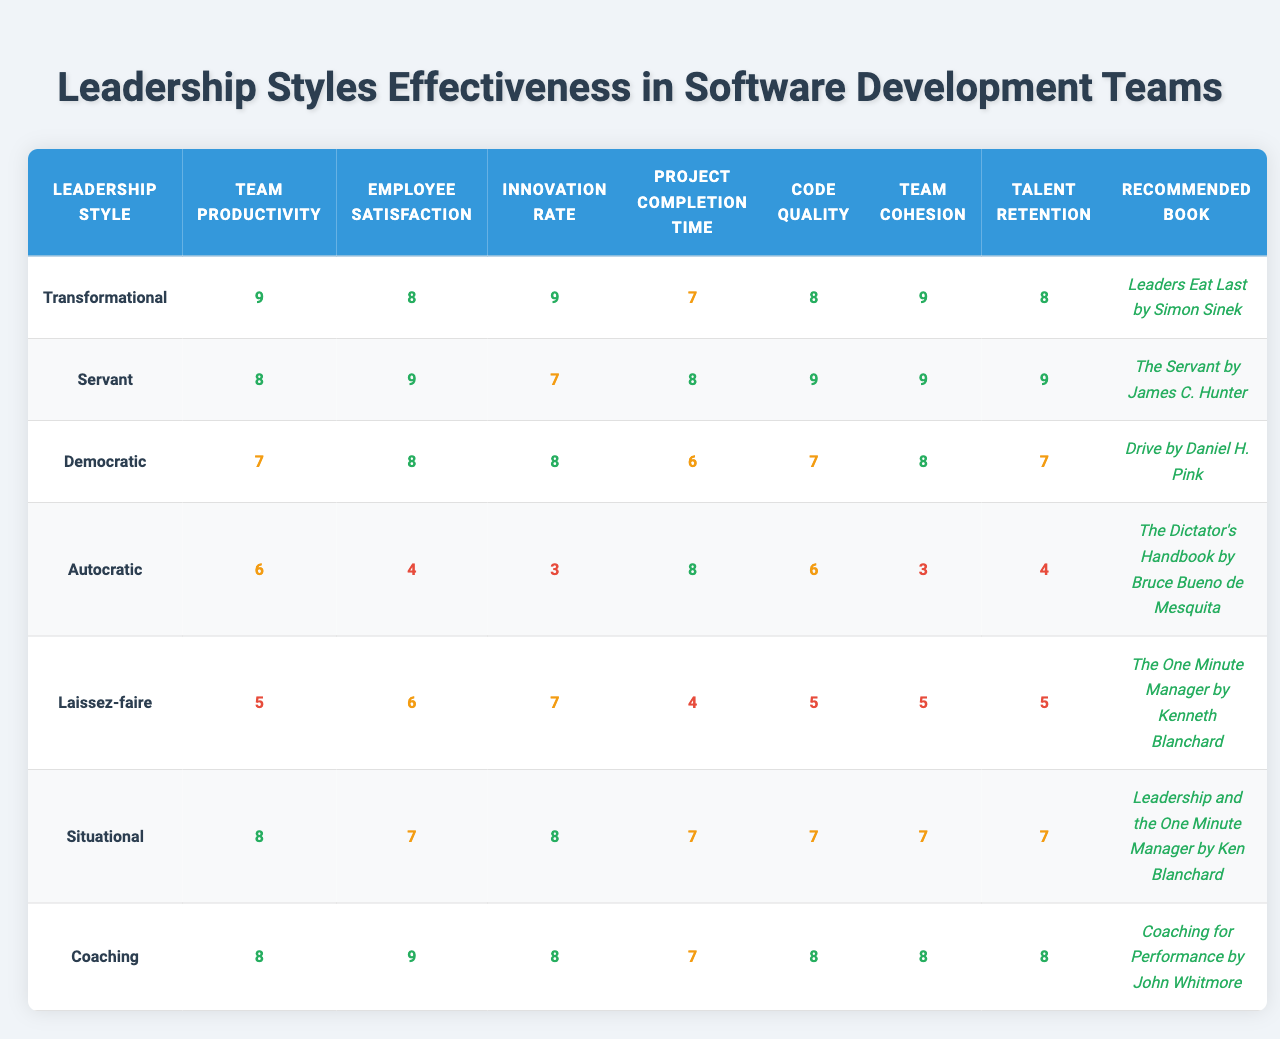What is the recommended book for the Transformational leadership style? According to the table, the recommended book for the Transformational leadership style is "Leaders Eat Last by Simon Sinek."
Answer: Leaders Eat Last by Simon Sinek Which leadership style has the highest score in Employee Satisfaction? The Employee Satisfaction scores for all styles are compared. The Servant leadership style has the highest score of 9.
Answer: Servant What is the average score for Team Cohesion across all leadership styles? The Team Cohesion scores are 9, 9, 8, 3, 5, 7, and 8. Adding these gives 49, and dividing by 7 (the number of styles) gives an average of 7.
Answer: 7 Does the Autocratic leadership style have a higher Innovation Rate than the Democratic style? The Innovation Rate for Autocratic is 3, while for Democratic it is 8. Since 3 is less than 8, the statement is false.
Answer: No What is the difference in Team Productivity between the Transformational and Laissez-faire leadership styles? Team Productivity for Transformational is 9 and for Laissez-faire is 5. The difference is 9 - 5 = 4.
Answer: 4 Which leadership style is associated with the lowest Code Quality score? The Code Quality scores are compared, and Autocratic has the lowest score of 6, making it the answer.
Answer: Autocratic If we consider the Talent Retention scores, which leadership style stands out as having a consistent high score? The scores for Talent Retention are 8, 9, 7, 4, 5, 7, and 8. The Servant style has the highest & consistent score of 9, indicating strong retention.
Answer: Servant What is the highest Project Completion Time score among all leadership styles? The Project Completion Time scores are 7, 8, 6, 8, 4, 7, and 7. The highest score is 8 from both Servant and Autocratic styles.
Answer: 8 Which leadership style has the lowest Team Cohesion score? Looking at the Team Cohesion scores, Autocratic has the lowest score of 3 when compared to others.
Answer: Autocratic Is there a leadership style that scores above 8 in both Team Productivity and Innovation Rate? Transformational scores 9 in Team Productivity and 9 in Innovation Rate, meeting the condition for being above 8 in both metrics, making it a yes.
Answer: Yes 